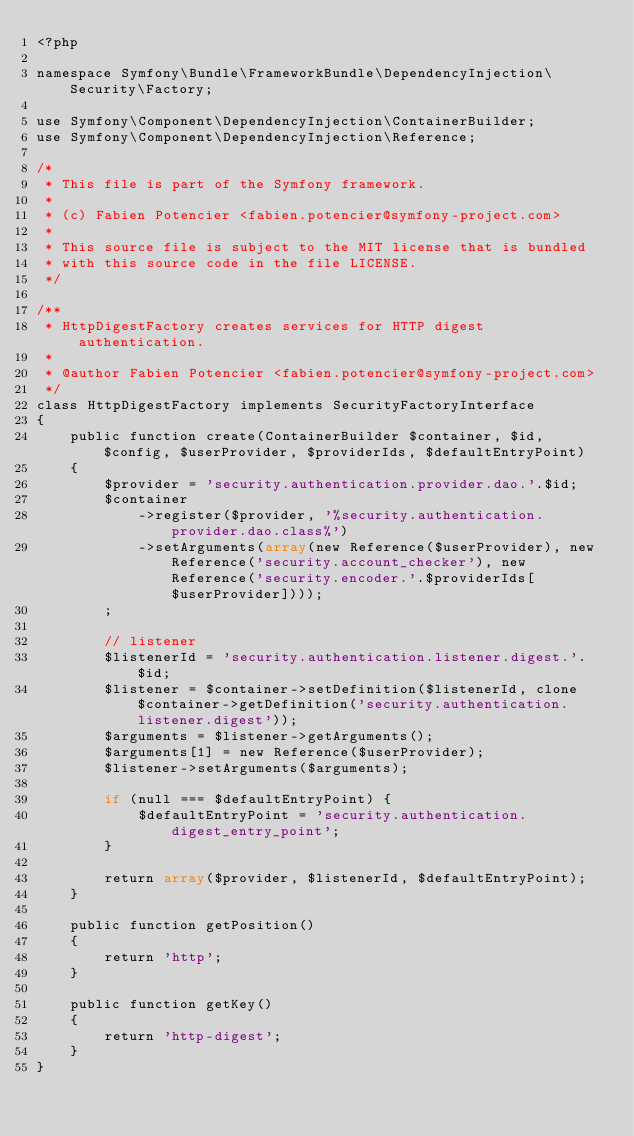<code> <loc_0><loc_0><loc_500><loc_500><_PHP_><?php

namespace Symfony\Bundle\FrameworkBundle\DependencyInjection\Security\Factory;

use Symfony\Component\DependencyInjection\ContainerBuilder;
use Symfony\Component\DependencyInjection\Reference;

/*
 * This file is part of the Symfony framework.
 *
 * (c) Fabien Potencier <fabien.potencier@symfony-project.com>
 *
 * This source file is subject to the MIT license that is bundled
 * with this source code in the file LICENSE.
 */

/**
 * HttpDigestFactory creates services for HTTP digest authentication.
 *
 * @author Fabien Potencier <fabien.potencier@symfony-project.com>
 */
class HttpDigestFactory implements SecurityFactoryInterface
{
    public function create(ContainerBuilder $container, $id, $config, $userProvider, $providerIds, $defaultEntryPoint)
    {
        $provider = 'security.authentication.provider.dao.'.$id;
        $container
            ->register($provider, '%security.authentication.provider.dao.class%')
            ->setArguments(array(new Reference($userProvider), new Reference('security.account_checker'), new Reference('security.encoder.'.$providerIds[$userProvider])));
        ;

        // listener
        $listenerId = 'security.authentication.listener.digest.'.$id;
        $listener = $container->setDefinition($listenerId, clone $container->getDefinition('security.authentication.listener.digest'));
        $arguments = $listener->getArguments();
        $arguments[1] = new Reference($userProvider);
        $listener->setArguments($arguments);

        if (null === $defaultEntryPoint) {
            $defaultEntryPoint = 'security.authentication.digest_entry_point';
        }

        return array($provider, $listenerId, $defaultEntryPoint);
    }

    public function getPosition()
    {
        return 'http';
    }

    public function getKey()
    {
        return 'http-digest';
    }
}
</code> 